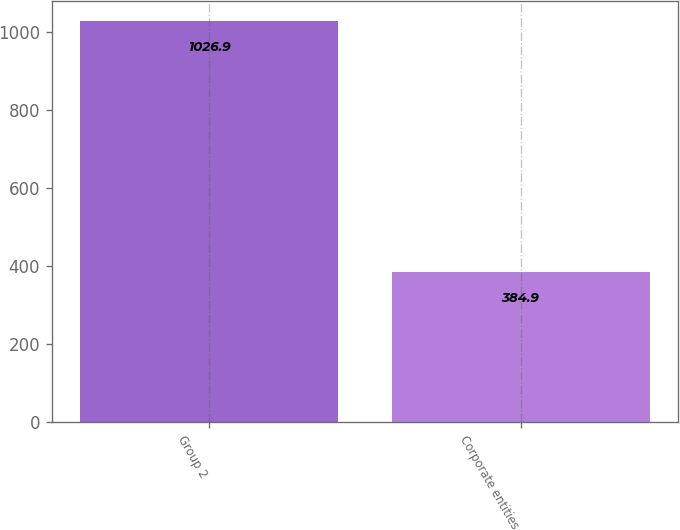Convert chart to OTSL. <chart><loc_0><loc_0><loc_500><loc_500><bar_chart><fcel>Group 2<fcel>Corporate entities<nl><fcel>1026.9<fcel>384.9<nl></chart> 